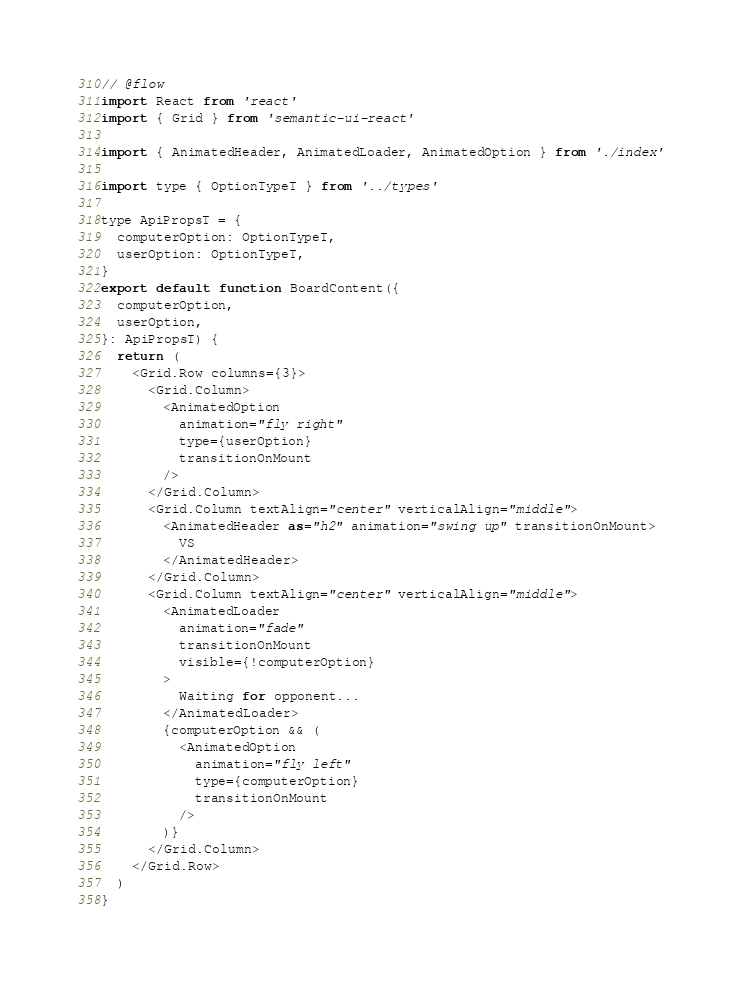<code> <loc_0><loc_0><loc_500><loc_500><_JavaScript_>// @flow
import React from 'react'
import { Grid } from 'semantic-ui-react'

import { AnimatedHeader, AnimatedLoader, AnimatedOption } from './index'

import type { OptionTypeT } from '../types'

type ApiPropsT = {
  computerOption: OptionTypeT,
  userOption: OptionTypeT,
}
export default function BoardContent({
  computerOption,
  userOption,
}: ApiPropsT) {
  return (
    <Grid.Row columns={3}>
      <Grid.Column>
        <AnimatedOption
          animation="fly right"
          type={userOption}
          transitionOnMount
        />
      </Grid.Column>
      <Grid.Column textAlign="center" verticalAlign="middle">
        <AnimatedHeader as="h2" animation="swing up" transitionOnMount>
          VS
        </AnimatedHeader>
      </Grid.Column>
      <Grid.Column textAlign="center" verticalAlign="middle">
        <AnimatedLoader
          animation="fade"
          transitionOnMount
          visible={!computerOption}
        >
          Waiting for opponent...
        </AnimatedLoader>
        {computerOption && (
          <AnimatedOption
            animation="fly left"
            type={computerOption}
            transitionOnMount
          />
        )}
      </Grid.Column>
    </Grid.Row>
  )
}
</code> 